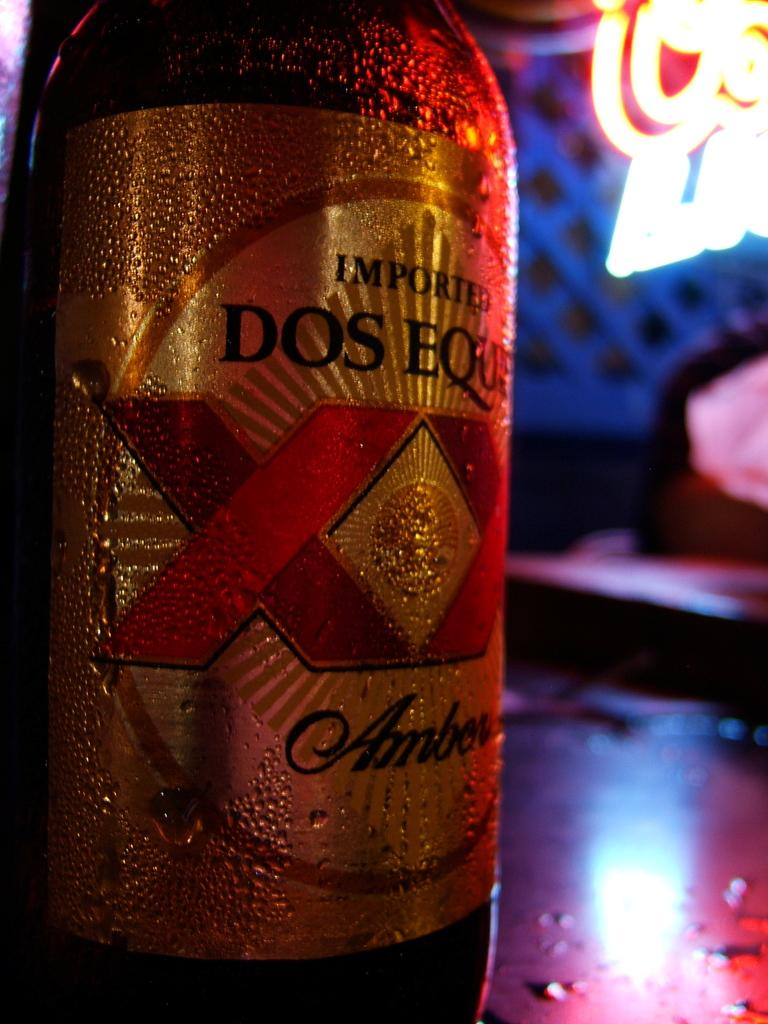<image>
Summarize the visual content of the image. A bottle of Dos Equis is ice cold on a table 